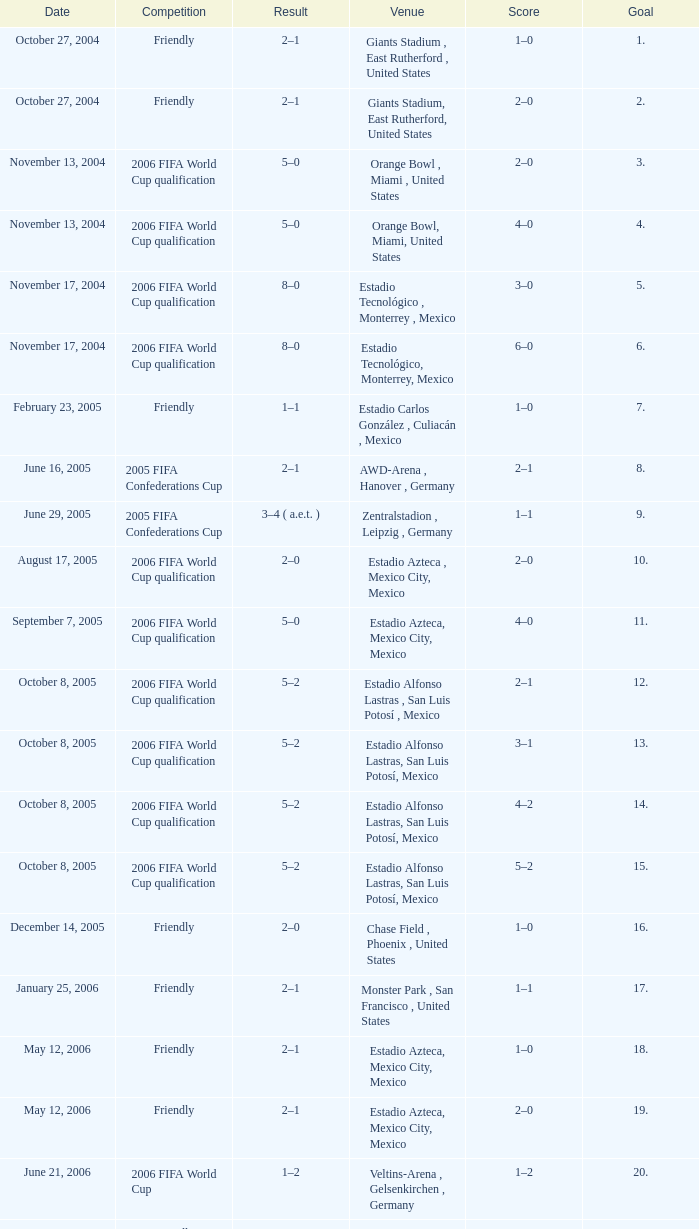Which Score has a Result of 2–1, and a Competition of friendly, and a Goal smaller than 17? 1–0, 2–0. 